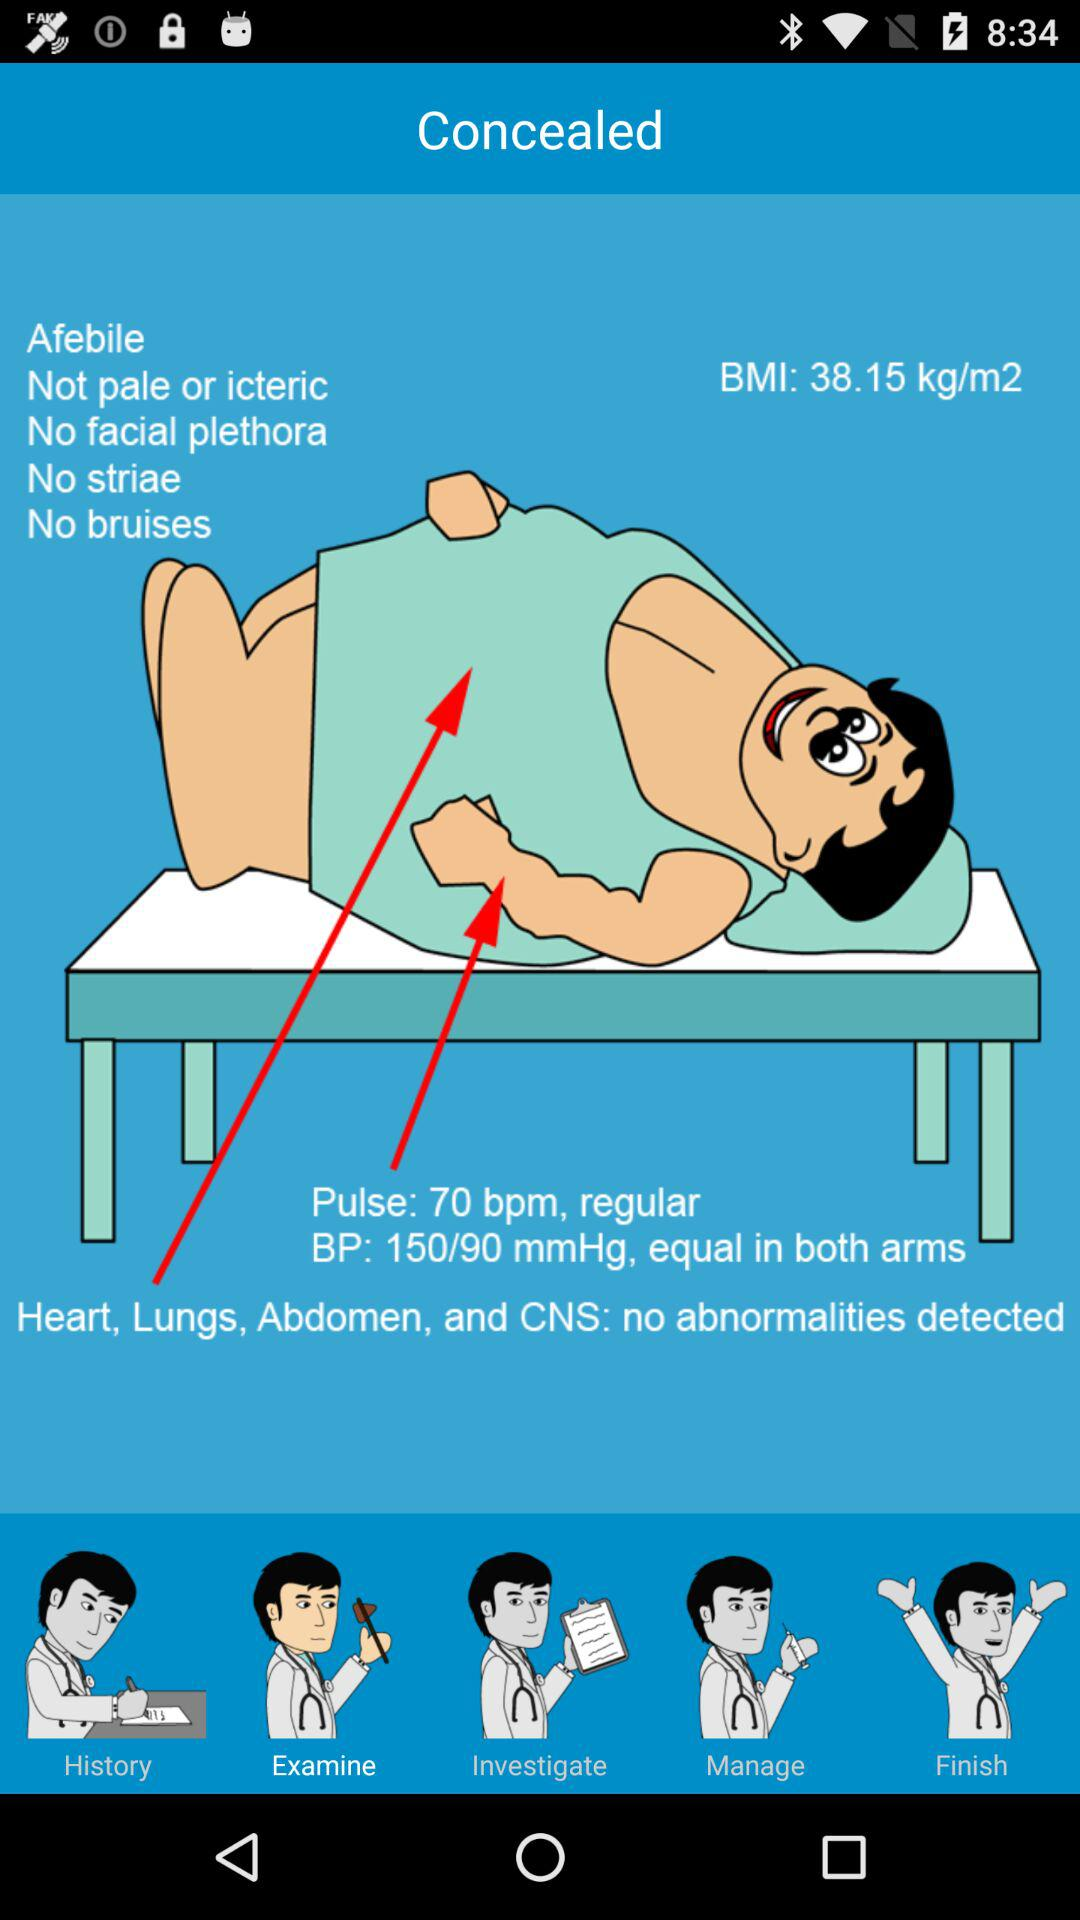What is the pulse rate? The pulse rate is 70 bpm. 